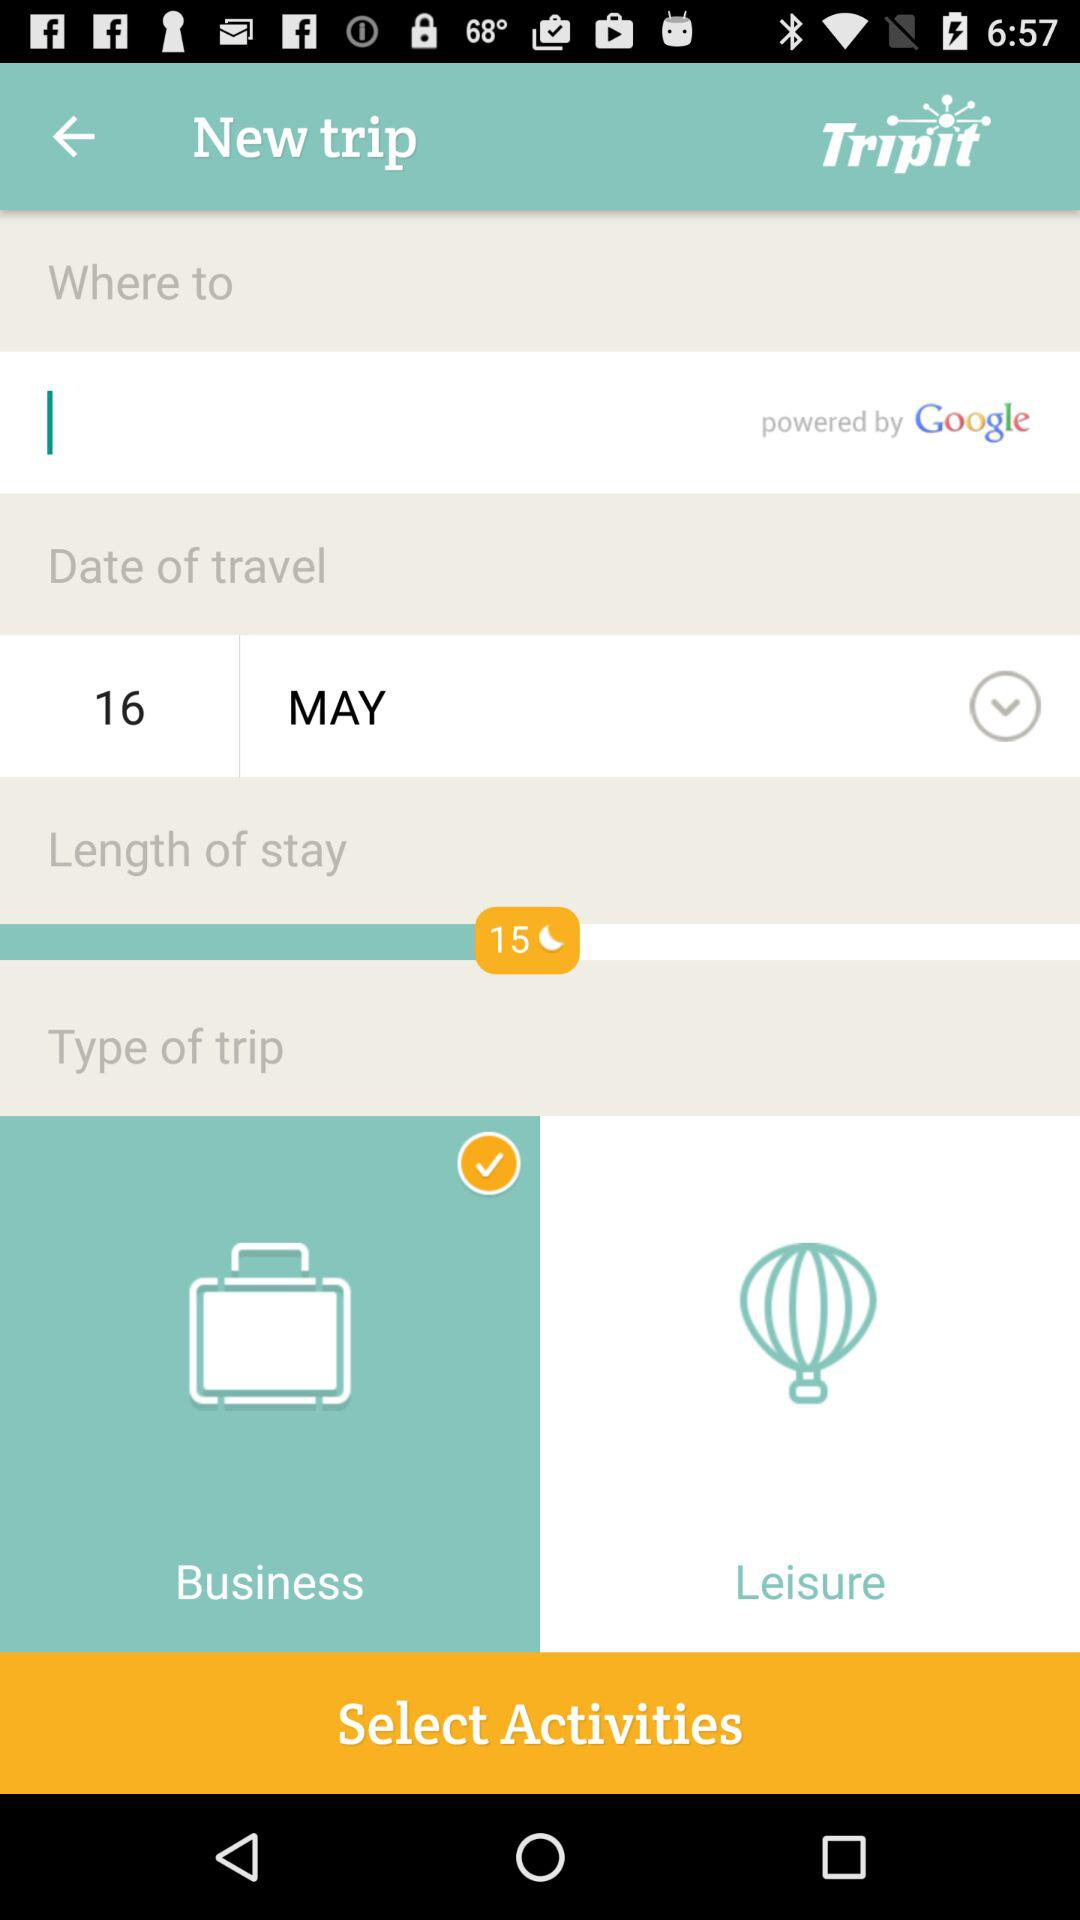What is the destination?
When the provided information is insufficient, respond with <no answer>. <no answer> 